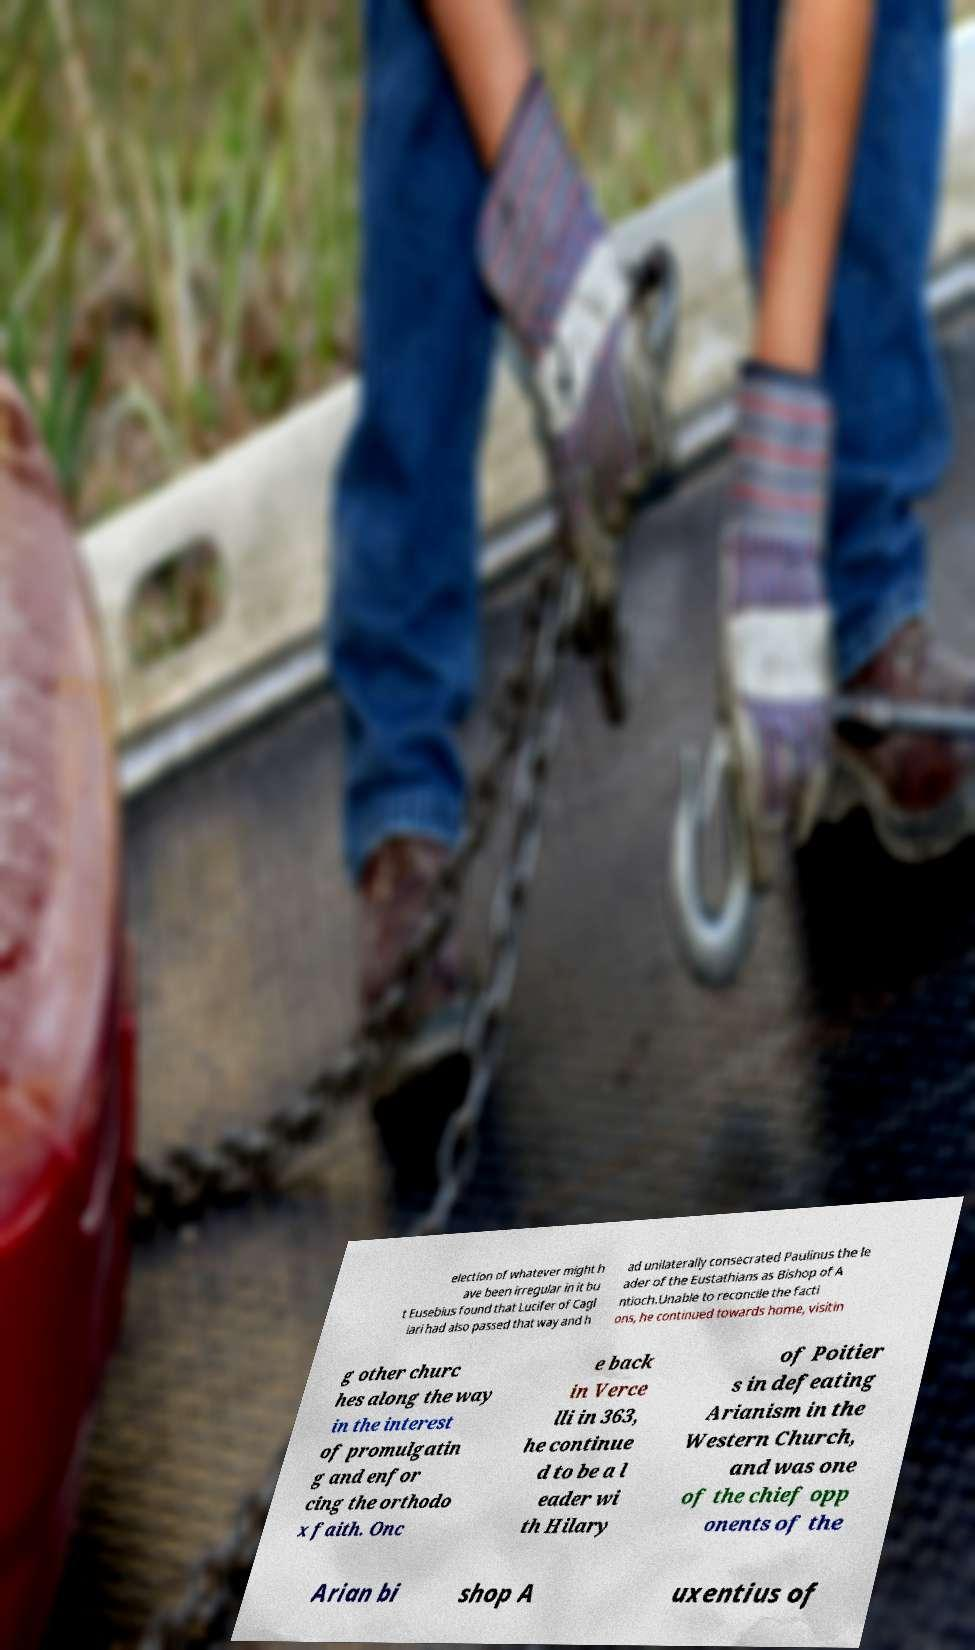I need the written content from this picture converted into text. Can you do that? election of whatever might h ave been irregular in it bu t Eusebius found that Lucifer of Cagl iari had also passed that way and h ad unilaterally consecrated Paulinus the le ader of the Eustathians as Bishop of A ntioch.Unable to reconcile the facti ons, he continued towards home, visitin g other churc hes along the way in the interest of promulgatin g and enfor cing the orthodo x faith. Onc e back in Verce lli in 363, he continue d to be a l eader wi th Hilary of Poitier s in defeating Arianism in the Western Church, and was one of the chief opp onents of the Arian bi shop A uxentius of 